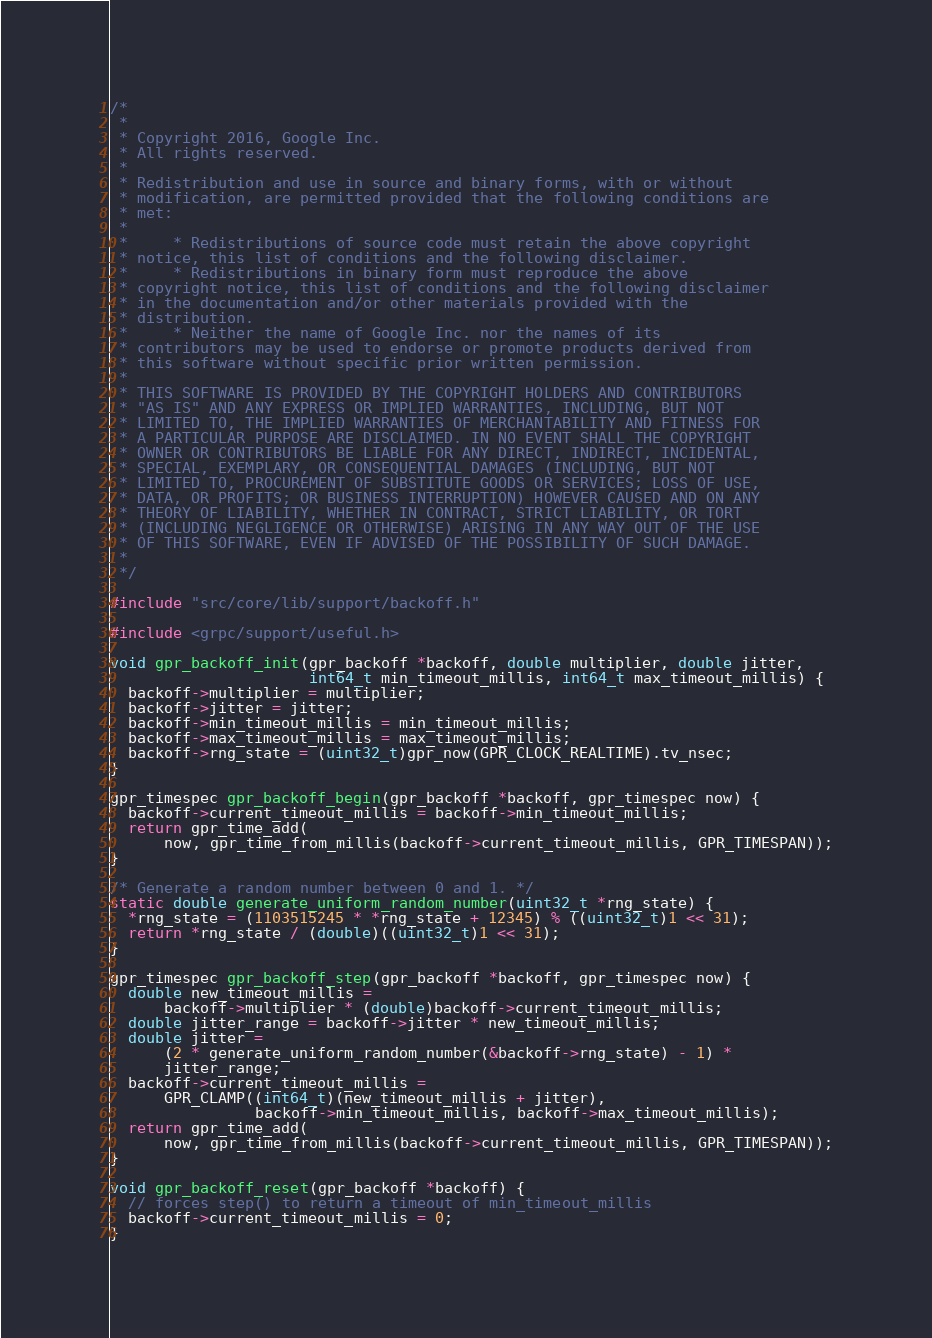<code> <loc_0><loc_0><loc_500><loc_500><_C_>/*
 *
 * Copyright 2016, Google Inc.
 * All rights reserved.
 *
 * Redistribution and use in source and binary forms, with or without
 * modification, are permitted provided that the following conditions are
 * met:
 *
 *     * Redistributions of source code must retain the above copyright
 * notice, this list of conditions and the following disclaimer.
 *     * Redistributions in binary form must reproduce the above
 * copyright notice, this list of conditions and the following disclaimer
 * in the documentation and/or other materials provided with the
 * distribution.
 *     * Neither the name of Google Inc. nor the names of its
 * contributors may be used to endorse or promote products derived from
 * this software without specific prior written permission.
 *
 * THIS SOFTWARE IS PROVIDED BY THE COPYRIGHT HOLDERS AND CONTRIBUTORS
 * "AS IS" AND ANY EXPRESS OR IMPLIED WARRANTIES, INCLUDING, BUT NOT
 * LIMITED TO, THE IMPLIED WARRANTIES OF MERCHANTABILITY AND FITNESS FOR
 * A PARTICULAR PURPOSE ARE DISCLAIMED. IN NO EVENT SHALL THE COPYRIGHT
 * OWNER OR CONTRIBUTORS BE LIABLE FOR ANY DIRECT, INDIRECT, INCIDENTAL,
 * SPECIAL, EXEMPLARY, OR CONSEQUENTIAL DAMAGES (INCLUDING, BUT NOT
 * LIMITED TO, PROCUREMENT OF SUBSTITUTE GOODS OR SERVICES; LOSS OF USE,
 * DATA, OR PROFITS; OR BUSINESS INTERRUPTION) HOWEVER CAUSED AND ON ANY
 * THEORY OF LIABILITY, WHETHER IN CONTRACT, STRICT LIABILITY, OR TORT
 * (INCLUDING NEGLIGENCE OR OTHERWISE) ARISING IN ANY WAY OUT OF THE USE
 * OF THIS SOFTWARE, EVEN IF ADVISED OF THE POSSIBILITY OF SUCH DAMAGE.
 *
 */

#include "src/core/lib/support/backoff.h"

#include <grpc/support/useful.h>

void gpr_backoff_init(gpr_backoff *backoff, double multiplier, double jitter,
                      int64_t min_timeout_millis, int64_t max_timeout_millis) {
  backoff->multiplier = multiplier;
  backoff->jitter = jitter;
  backoff->min_timeout_millis = min_timeout_millis;
  backoff->max_timeout_millis = max_timeout_millis;
  backoff->rng_state = (uint32_t)gpr_now(GPR_CLOCK_REALTIME).tv_nsec;
}

gpr_timespec gpr_backoff_begin(gpr_backoff *backoff, gpr_timespec now) {
  backoff->current_timeout_millis = backoff->min_timeout_millis;
  return gpr_time_add(
      now, gpr_time_from_millis(backoff->current_timeout_millis, GPR_TIMESPAN));
}

/* Generate a random number between 0 and 1. */
static double generate_uniform_random_number(uint32_t *rng_state) {
  *rng_state = (1103515245 * *rng_state + 12345) % ((uint32_t)1 << 31);
  return *rng_state / (double)((uint32_t)1 << 31);
}

gpr_timespec gpr_backoff_step(gpr_backoff *backoff, gpr_timespec now) {
  double new_timeout_millis =
      backoff->multiplier * (double)backoff->current_timeout_millis;
  double jitter_range = backoff->jitter * new_timeout_millis;
  double jitter =
      (2 * generate_uniform_random_number(&backoff->rng_state) - 1) *
      jitter_range;
  backoff->current_timeout_millis =
      GPR_CLAMP((int64_t)(new_timeout_millis + jitter),
                backoff->min_timeout_millis, backoff->max_timeout_millis);
  return gpr_time_add(
      now, gpr_time_from_millis(backoff->current_timeout_millis, GPR_TIMESPAN));
}

void gpr_backoff_reset(gpr_backoff *backoff) {
  // forces step() to return a timeout of min_timeout_millis
  backoff->current_timeout_millis = 0;
}
</code> 